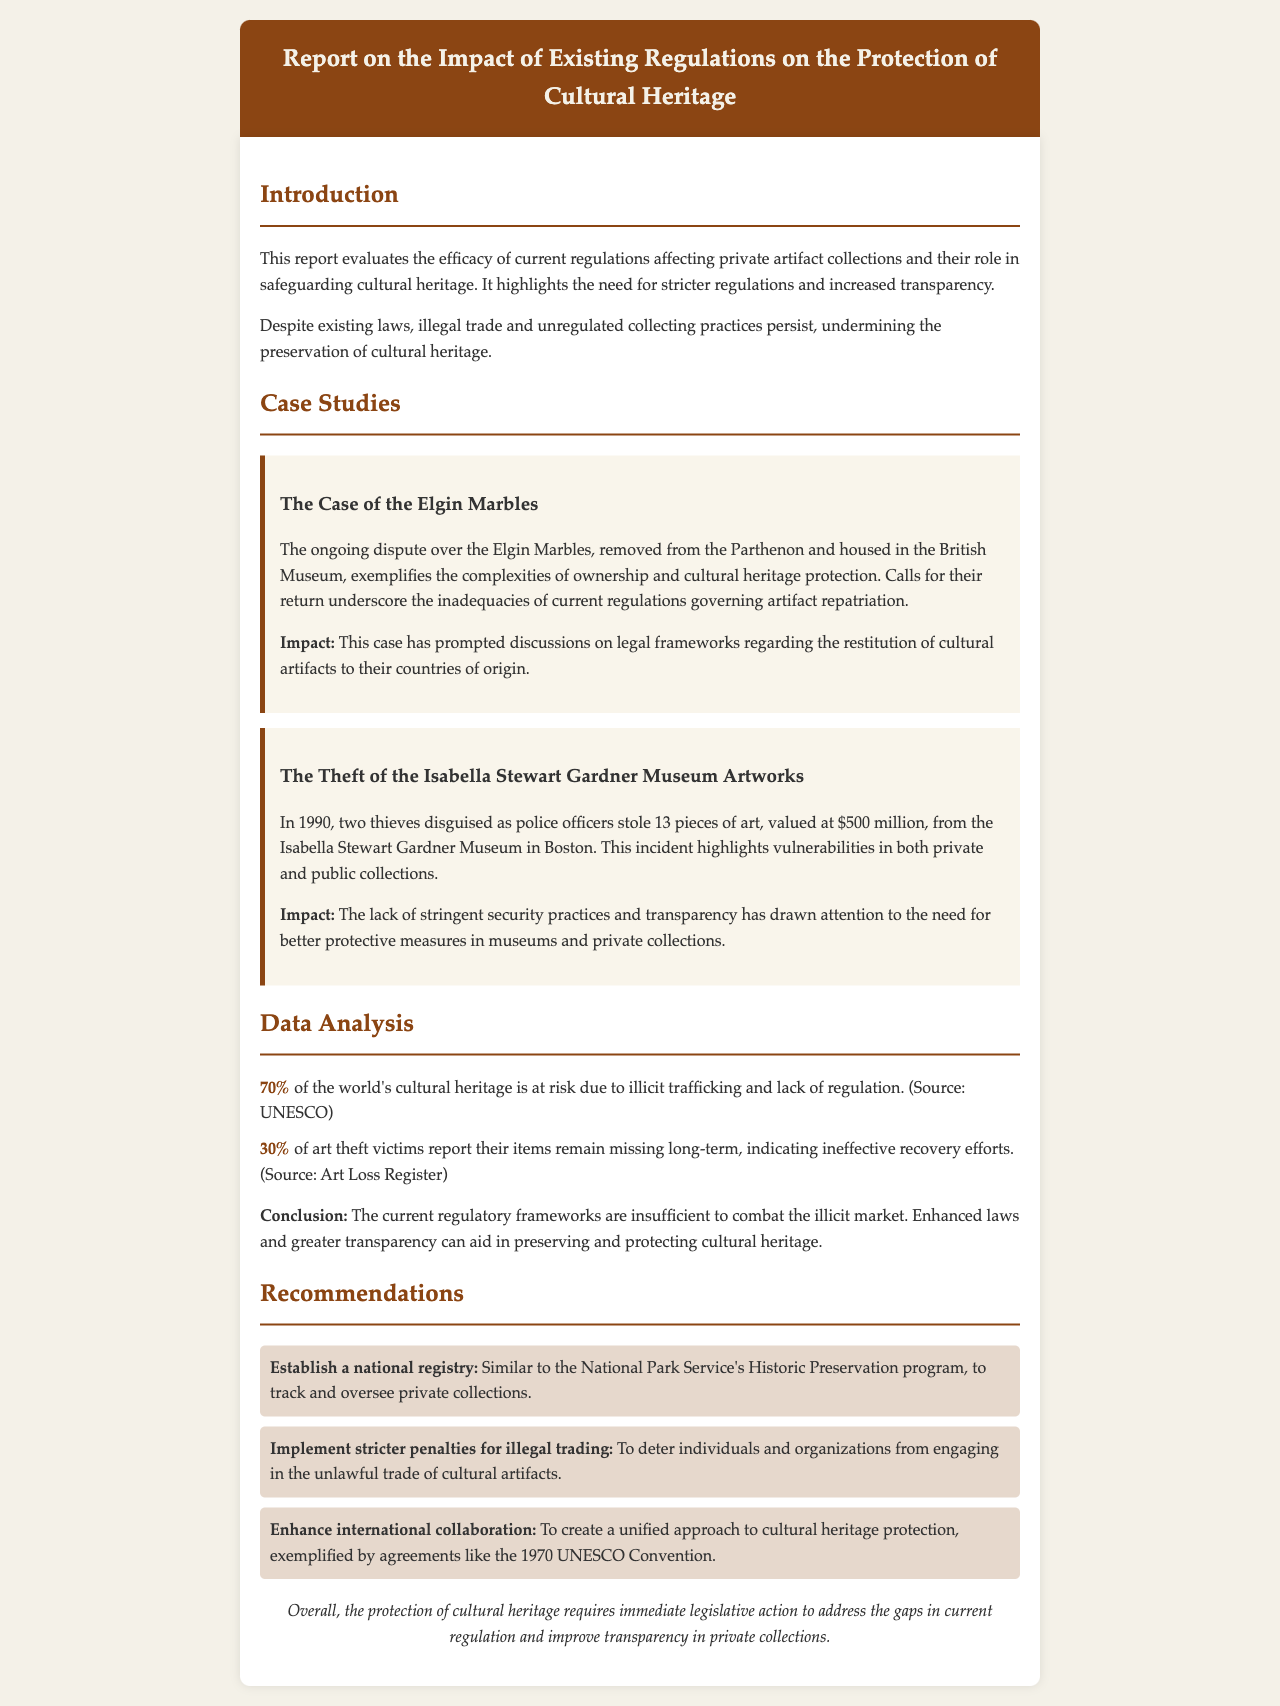What is the main focus of the report? The report evaluates the efficacy of current regulations affecting private artifact collections and their role in safeguarding cultural heritage.
Answer: safeguarding cultural heritage What is the impact of the Elgin Marbles case? The Elgin Marbles case has prompted discussions on legal frameworks regarding the restitution of cultural artifacts to their countries of origin.
Answer: restitution of cultural artifacts How much of the world's cultural heritage is at risk due to illicit trafficking? The statistic provided in the document states that 70% of the world's cultural heritage is at risk due to illicit trafficking and lack of regulation.
Answer: 70% What year did the Isabella Stewart Gardner Museum theft occur? The theft took place in 1990.
Answer: 1990 What is one recommendation made in the report? The report recommends establishing a national registry to track and oversee private collections.
Answer: national registry What percentage of art theft victims report their items remain missing? The report indicates that 30% of art theft victims report their items remain missing long-term.
Answer: 30% What does the report suggest is necessary for the protection of cultural heritage? The report concludes that immediate legislative action is required to address the gaps in current regulation.
Answer: immediate legislative action What specific agreement is mentioned in relation to international collaboration? The document mentions the 1970 UNESCO Convention as an example of international collaboration.
Answer: 1970 UNESCO Convention 